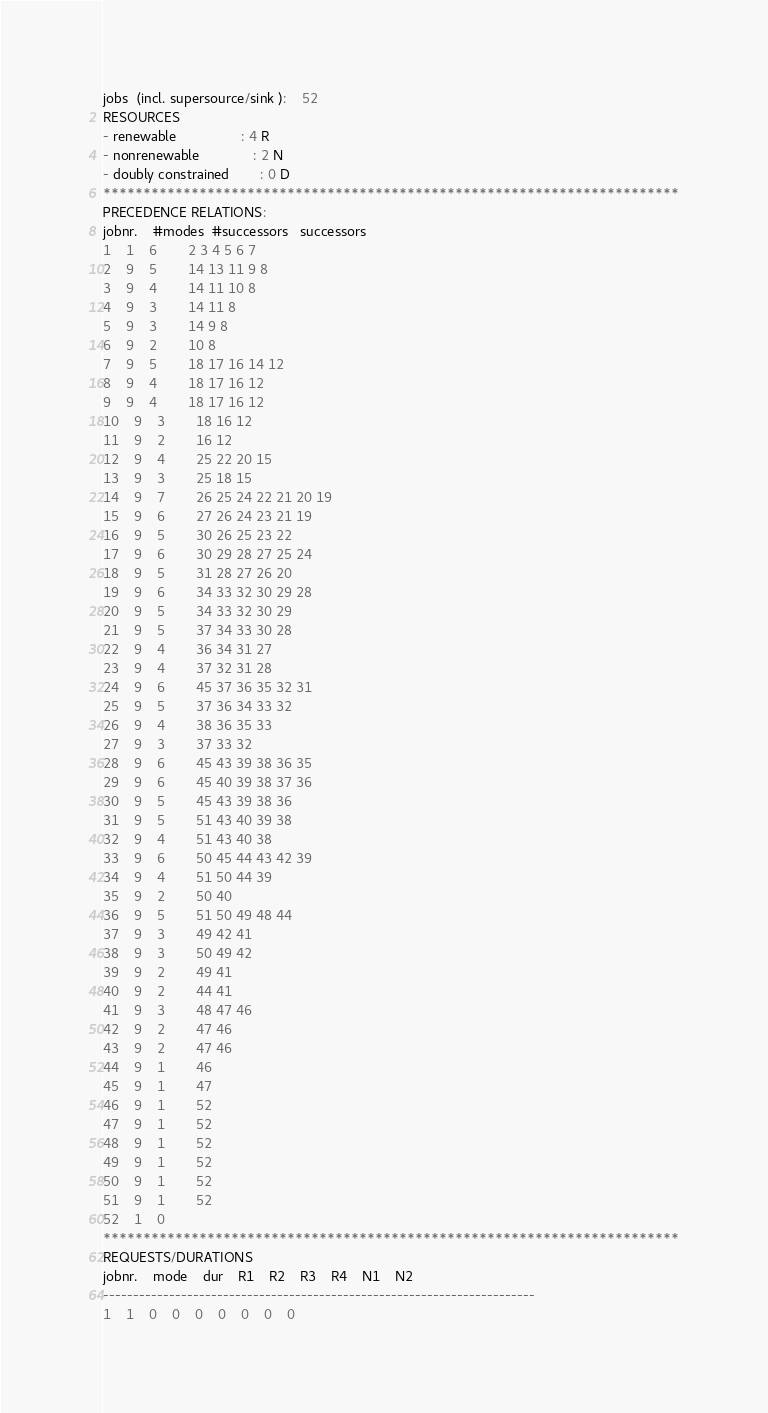<code> <loc_0><loc_0><loc_500><loc_500><_ObjectiveC_>jobs  (incl. supersource/sink ):	52
RESOURCES
- renewable                 : 4 R
- nonrenewable              : 2 N
- doubly constrained        : 0 D
************************************************************************
PRECEDENCE RELATIONS:
jobnr.    #modes  #successors   successors
1	1	6		2 3 4 5 6 7 
2	9	5		14 13 11 9 8 
3	9	4		14 11 10 8 
4	9	3		14 11 8 
5	9	3		14 9 8 
6	9	2		10 8 
7	9	5		18 17 16 14 12 
8	9	4		18 17 16 12 
9	9	4		18 17 16 12 
10	9	3		18 16 12 
11	9	2		16 12 
12	9	4		25 22 20 15 
13	9	3		25 18 15 
14	9	7		26 25 24 22 21 20 19 
15	9	6		27 26 24 23 21 19 
16	9	5		30 26 25 23 22 
17	9	6		30 29 28 27 25 24 
18	9	5		31 28 27 26 20 
19	9	6		34 33 32 30 29 28 
20	9	5		34 33 32 30 29 
21	9	5		37 34 33 30 28 
22	9	4		36 34 31 27 
23	9	4		37 32 31 28 
24	9	6		45 37 36 35 32 31 
25	9	5		37 36 34 33 32 
26	9	4		38 36 35 33 
27	9	3		37 33 32 
28	9	6		45 43 39 38 36 35 
29	9	6		45 40 39 38 37 36 
30	9	5		45 43 39 38 36 
31	9	5		51 43 40 39 38 
32	9	4		51 43 40 38 
33	9	6		50 45 44 43 42 39 
34	9	4		51 50 44 39 
35	9	2		50 40 
36	9	5		51 50 49 48 44 
37	9	3		49 42 41 
38	9	3		50 49 42 
39	9	2		49 41 
40	9	2		44 41 
41	9	3		48 47 46 
42	9	2		47 46 
43	9	2		47 46 
44	9	1		46 
45	9	1		47 
46	9	1		52 
47	9	1		52 
48	9	1		52 
49	9	1		52 
50	9	1		52 
51	9	1		52 
52	1	0		
************************************************************************
REQUESTS/DURATIONS
jobnr.	mode	dur	R1	R2	R3	R4	N1	N2	
------------------------------------------------------------------------
1	1	0	0	0	0	0	0	0	</code> 